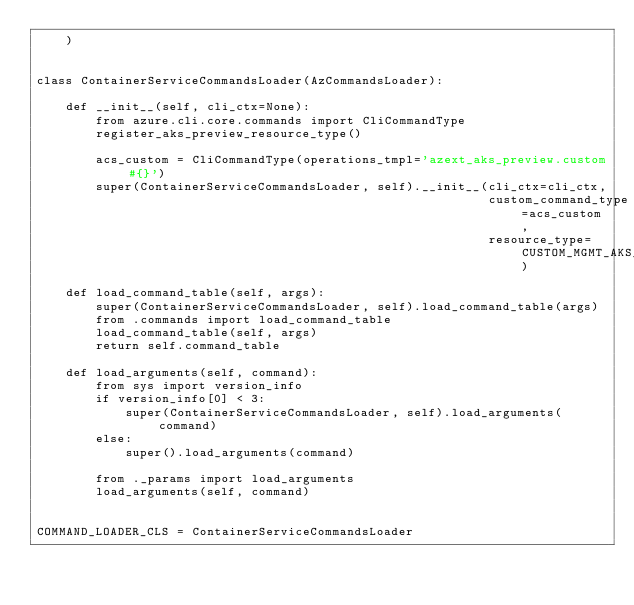Convert code to text. <code><loc_0><loc_0><loc_500><loc_500><_Python_>    )


class ContainerServiceCommandsLoader(AzCommandsLoader):

    def __init__(self, cli_ctx=None):
        from azure.cli.core.commands import CliCommandType
        register_aks_preview_resource_type()

        acs_custom = CliCommandType(operations_tmpl='azext_aks_preview.custom#{}')
        super(ContainerServiceCommandsLoader, self).__init__(cli_ctx=cli_ctx,
                                                             custom_command_type=acs_custom,
                                                             resource_type=CUSTOM_MGMT_AKS_PREVIEW)

    def load_command_table(self, args):
        super(ContainerServiceCommandsLoader, self).load_command_table(args)
        from .commands import load_command_table
        load_command_table(self, args)
        return self.command_table

    def load_arguments(self, command):
        from sys import version_info
        if version_info[0] < 3:
            super(ContainerServiceCommandsLoader, self).load_arguments(command)
        else:
            super().load_arguments(command)

        from ._params import load_arguments
        load_arguments(self, command)


COMMAND_LOADER_CLS = ContainerServiceCommandsLoader
</code> 